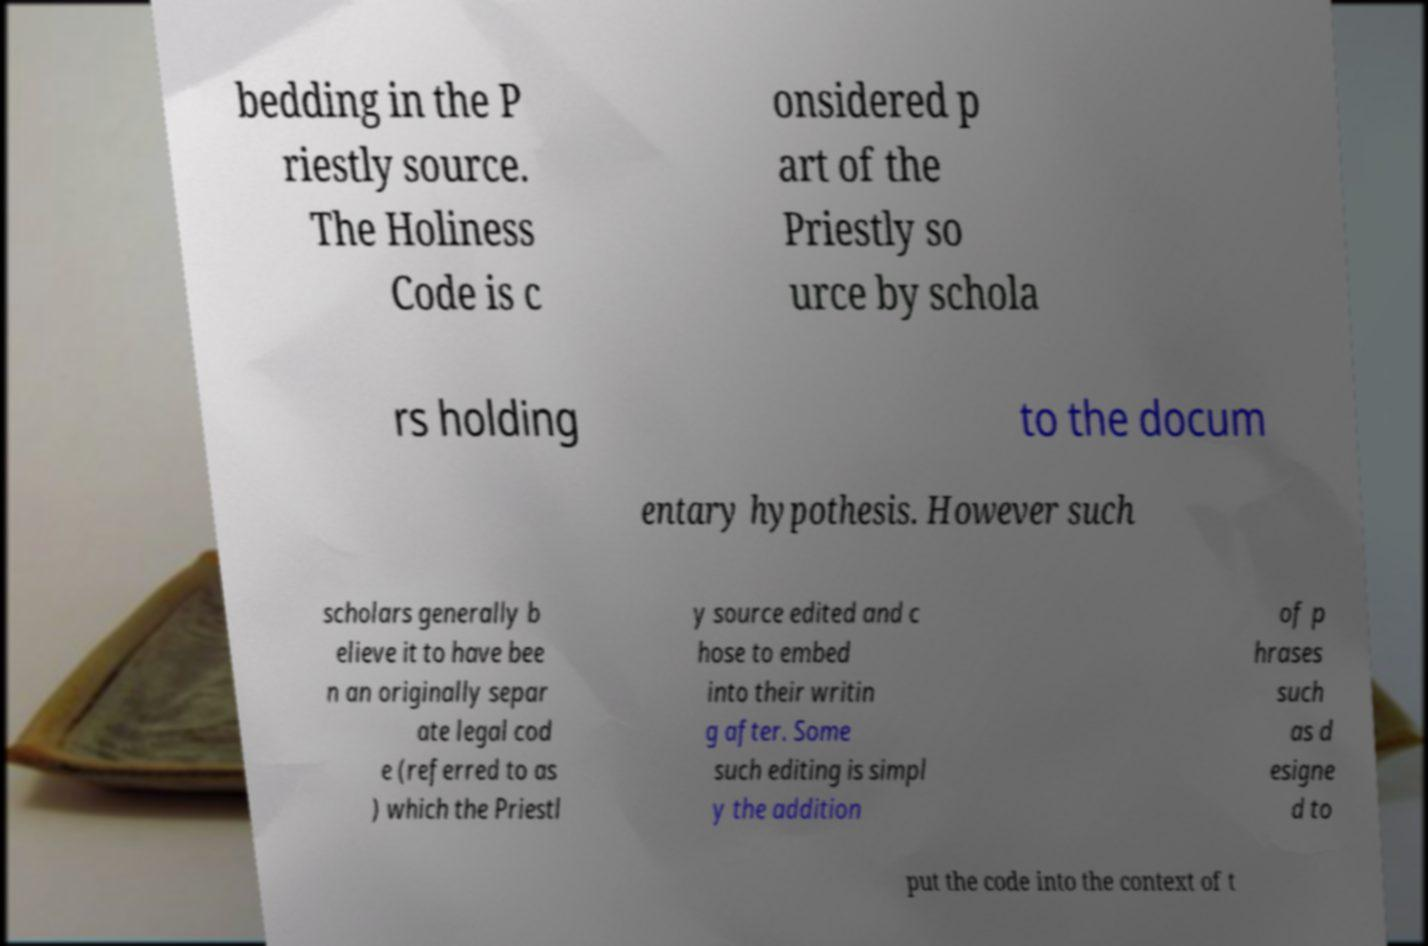Can you accurately transcribe the text from the provided image for me? bedding in the P riestly source. The Holiness Code is c onsidered p art of the Priestly so urce by schola rs holding to the docum entary hypothesis. However such scholars generally b elieve it to have bee n an originally separ ate legal cod e (referred to as ) which the Priestl y source edited and c hose to embed into their writin g after. Some such editing is simpl y the addition of p hrases such as d esigne d to put the code into the context of t 